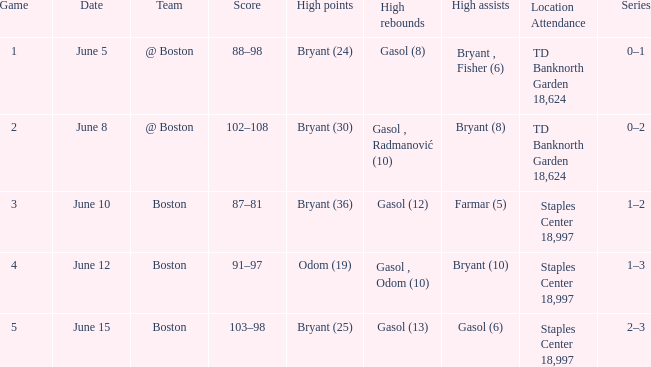Name the location on june 10 Staples Center 18,997. 